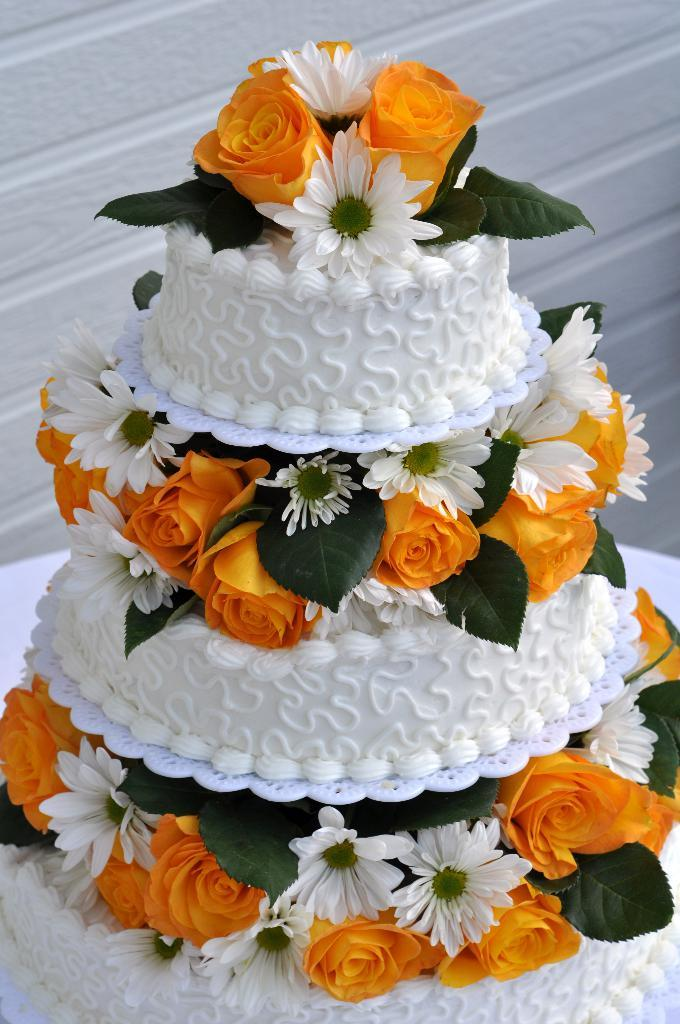What is the main subject of the image? There is a cake in the image. Where is the cake located? The cake is placed on a table. What decorations are on the cake? There are flowers on the cake, specifically in the middle and top. What can be seen in the background of the image? There is a wall in the background of the image. How many knees are visible in the image? There are no knees visible in the image; it features a cake on a table with flowers as decorations. What type of snakes can be seen slithering on the cake? There are no snakes present in the image; the cake is decorated with flowers. 